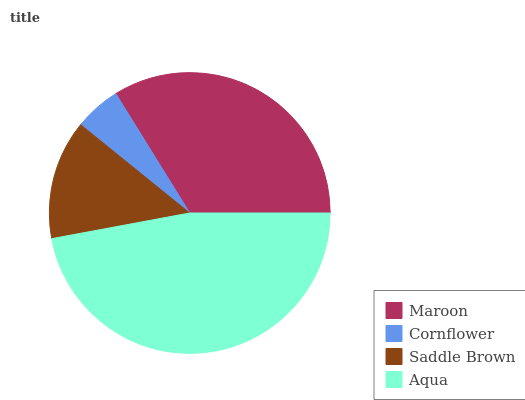Is Cornflower the minimum?
Answer yes or no. Yes. Is Aqua the maximum?
Answer yes or no. Yes. Is Saddle Brown the minimum?
Answer yes or no. No. Is Saddle Brown the maximum?
Answer yes or no. No. Is Saddle Brown greater than Cornflower?
Answer yes or no. Yes. Is Cornflower less than Saddle Brown?
Answer yes or no. Yes. Is Cornflower greater than Saddle Brown?
Answer yes or no. No. Is Saddle Brown less than Cornflower?
Answer yes or no. No. Is Maroon the high median?
Answer yes or no. Yes. Is Saddle Brown the low median?
Answer yes or no. Yes. Is Saddle Brown the high median?
Answer yes or no. No. Is Cornflower the low median?
Answer yes or no. No. 